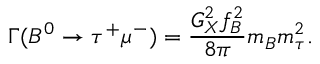<formula> <loc_0><loc_0><loc_500><loc_500>\Gamma ( B ^ { 0 } \rightarrow \tau ^ { + } \mu ^ { - } ) = { \frac { G _ { X } ^ { 2 } f _ { B } ^ { 2 } } { 8 \pi } } m _ { B } m _ { \tau } ^ { 2 } .</formula> 